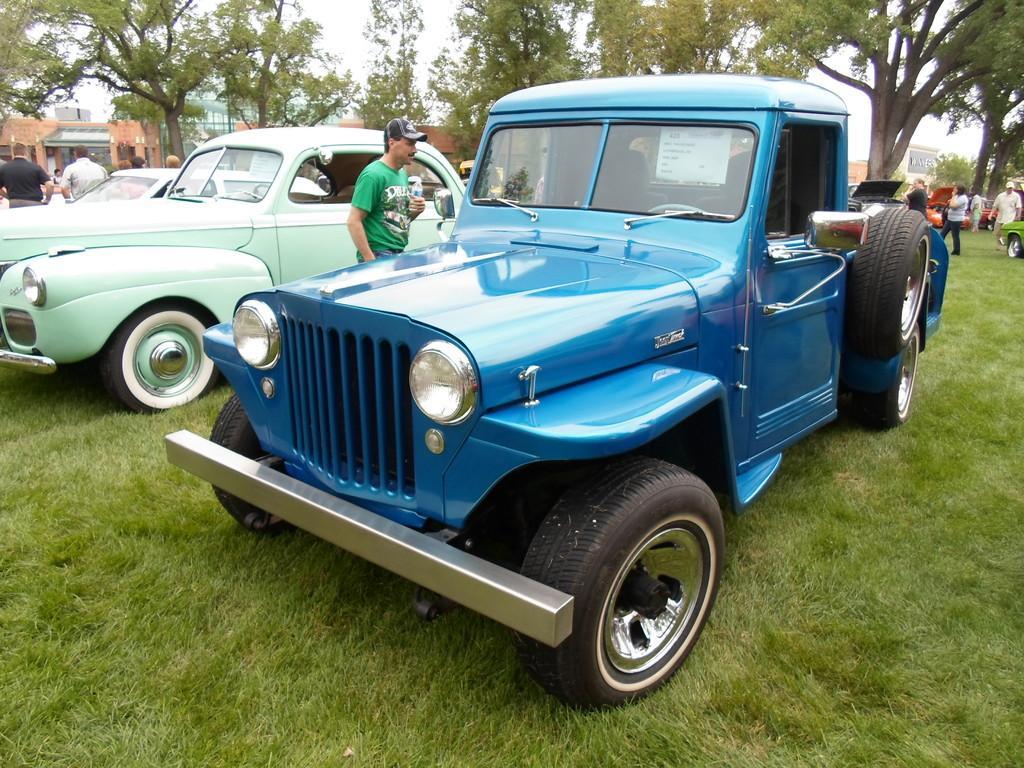In one or two sentences, can you explain what this image depicts? In this image we can see some cars parked on the grass. We can also see a person standing beside a car holding a bottle. On the backside we can see some people walking. We can also see some trees, buildings and the sky which looks cloudy. 